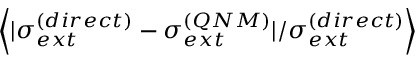Convert formula to latex. <formula><loc_0><loc_0><loc_500><loc_500>\left \langle | \sigma _ { e x t } ^ { ( d i r e c t ) } - \sigma _ { e x t } ^ { ( Q N M ) } | / \sigma _ { e x t } ^ { ( d i r e c t ) } \right \rangle</formula> 